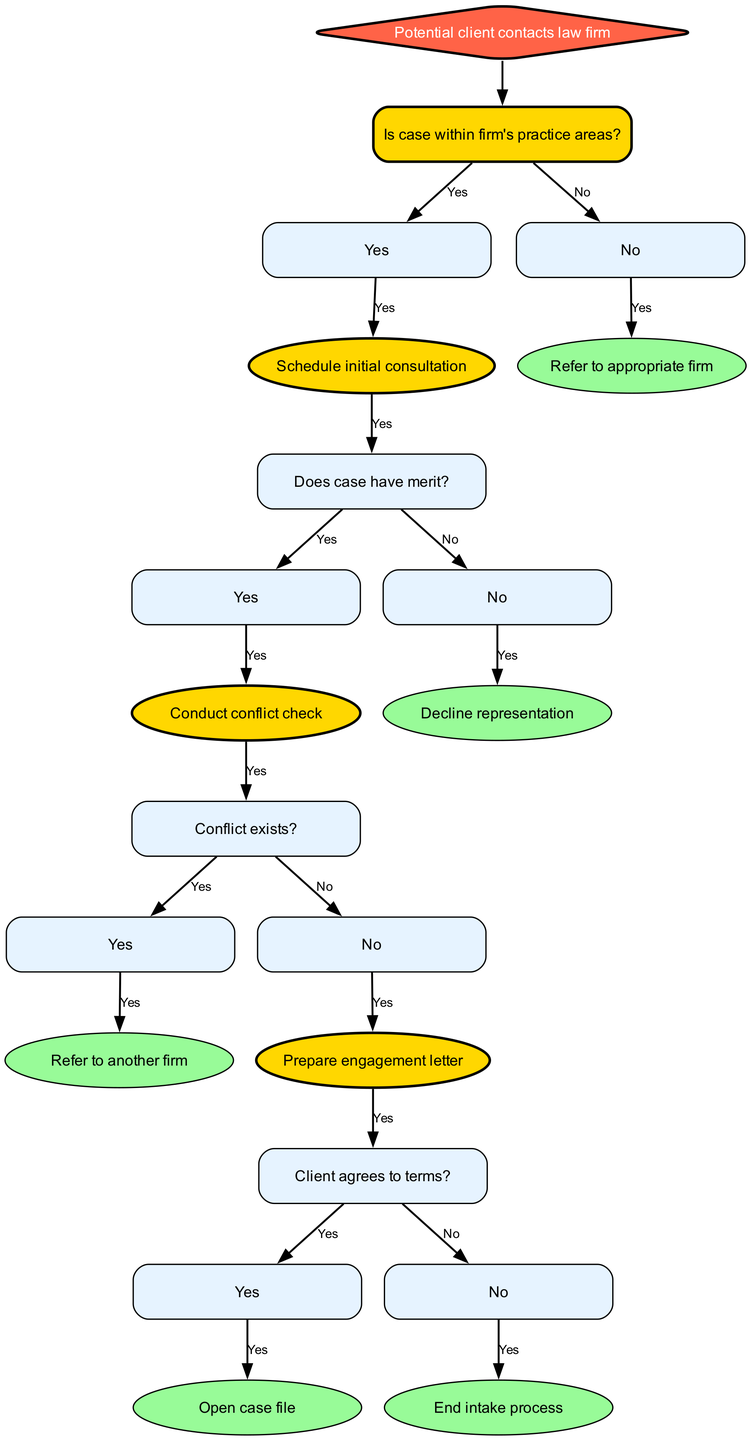What is the first action when a potential client contacts the law firm? The diagram indicates the first action is "Is case within firm's practice areas?" which is asked immediately after the potential client contacts the law firm.
Answer: Is case within firm's practice areas? How many potential outcomes follow from checking if the case is within the firm's practice areas? There are two possible outcomes after this decision: "Yes" leading to scheduling an initial consultation and "No" leading to referring to another firm.
Answer: Two What happens if the case has no merit? If the case has no merit, the decision tree specifies that the action taken is to "Decline representation." This occurs after the initial consultation is scheduled.
Answer: Decline representation If a conflict does exist, what is the next step? The next step if a conflict exists is to "Refer to another firm." This follows the conduct of a conflict check, where the existence of a conflict is determined.
Answer: Refer to another firm What must happen after preparing the engagement letter? After preparing the engagement letter, the next step is to check if "Client agrees to terms?" This determines how the process proceeds based on the client's response.
Answer: Client agrees to terms? What is required before opening a case file? Before opening a case file, the client's agreement to the terms must be obtained as specified after preparing the engagement letter.
Answer: Client agrees to terms? How many total nodes are there in this decision tree? The decision tree features a total of fifteen nodes, representing various steps and decisions throughout the case intake process.
Answer: Fifteen Which node directly follows the "Schedule initial consultation"? The node that directly follows "Schedule initial consultation" is "Does case have merit?" This shows the next step concerned with evaluating the case's value.
Answer: Does case have merit? What decision leads to referring a client to another firm? The decision to refer a client to another firm is made if a "Conflict exists?" during the conflict check process. This occurs if the answer is yes to that question.
Answer: Conflict exists? 